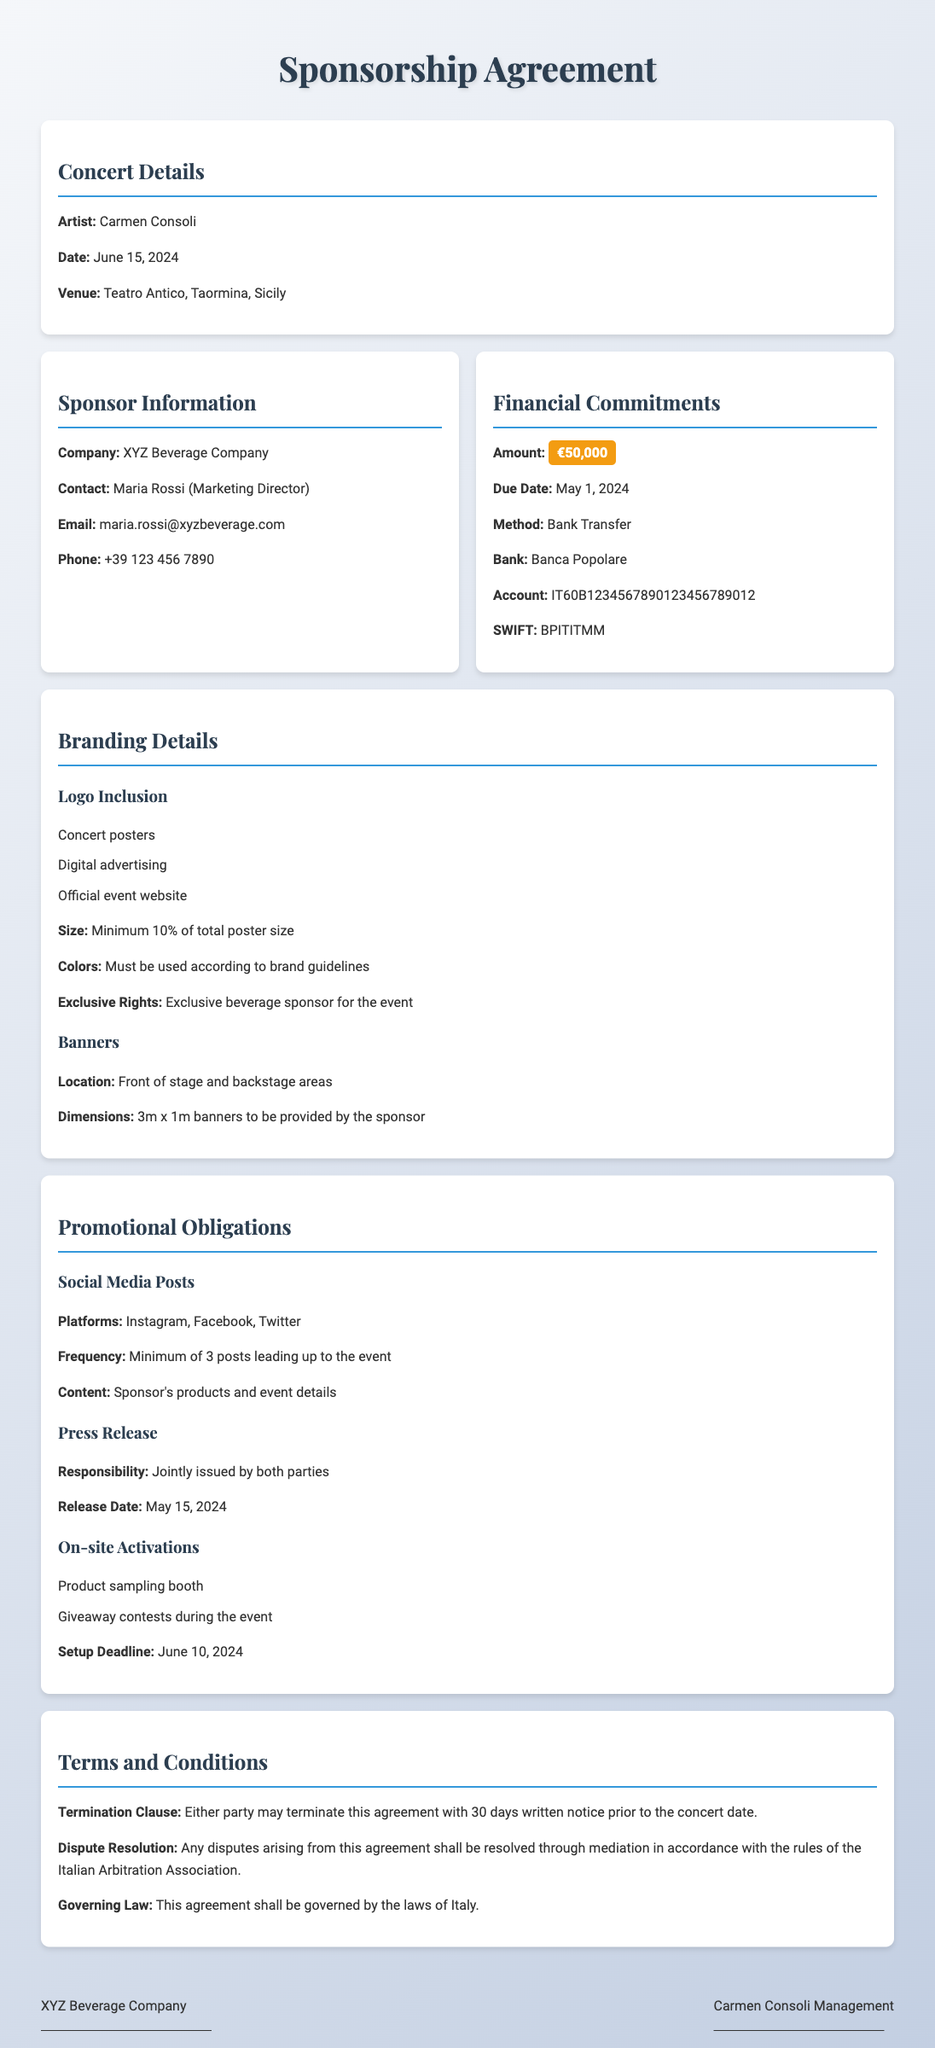What is the artist's name? The artist performing at the concert is stated in the concert details section.
Answer: Carmen Consoli What is the concert date? The date of the concert is specified in the concert details section.
Answer: June 15, 2024 What is the sponsorship amount? The financial commitment from the sponsor is clearly mentioned in the financial commitments section.
Answer: €50,000 What is the due date for payment? The due date for the financial commitment is provided in the financial commitments section.
Answer: May 1, 2024 What are the branding rights for the sponsor? The exclusive rights of the sponsor are mentioned under branding details.
Answer: Exclusive beverage sponsor How many social media posts are required? The number of social media posts that the sponsor must make is outlined in the promotional obligations section.
Answer: Minimum of 3 posts What will be included in the press release? The responsibility for the press release is specified in the promotional obligations section.
Answer: Jointly issued by both parties Where will the sponsors' banners be located? The location of the banners is described in the branding details section.
Answer: Front of stage and backstage areas What is the termination notice period? The termination clause outlines the required notice period before terminating the agreement.
Answer: 30 days written notice 